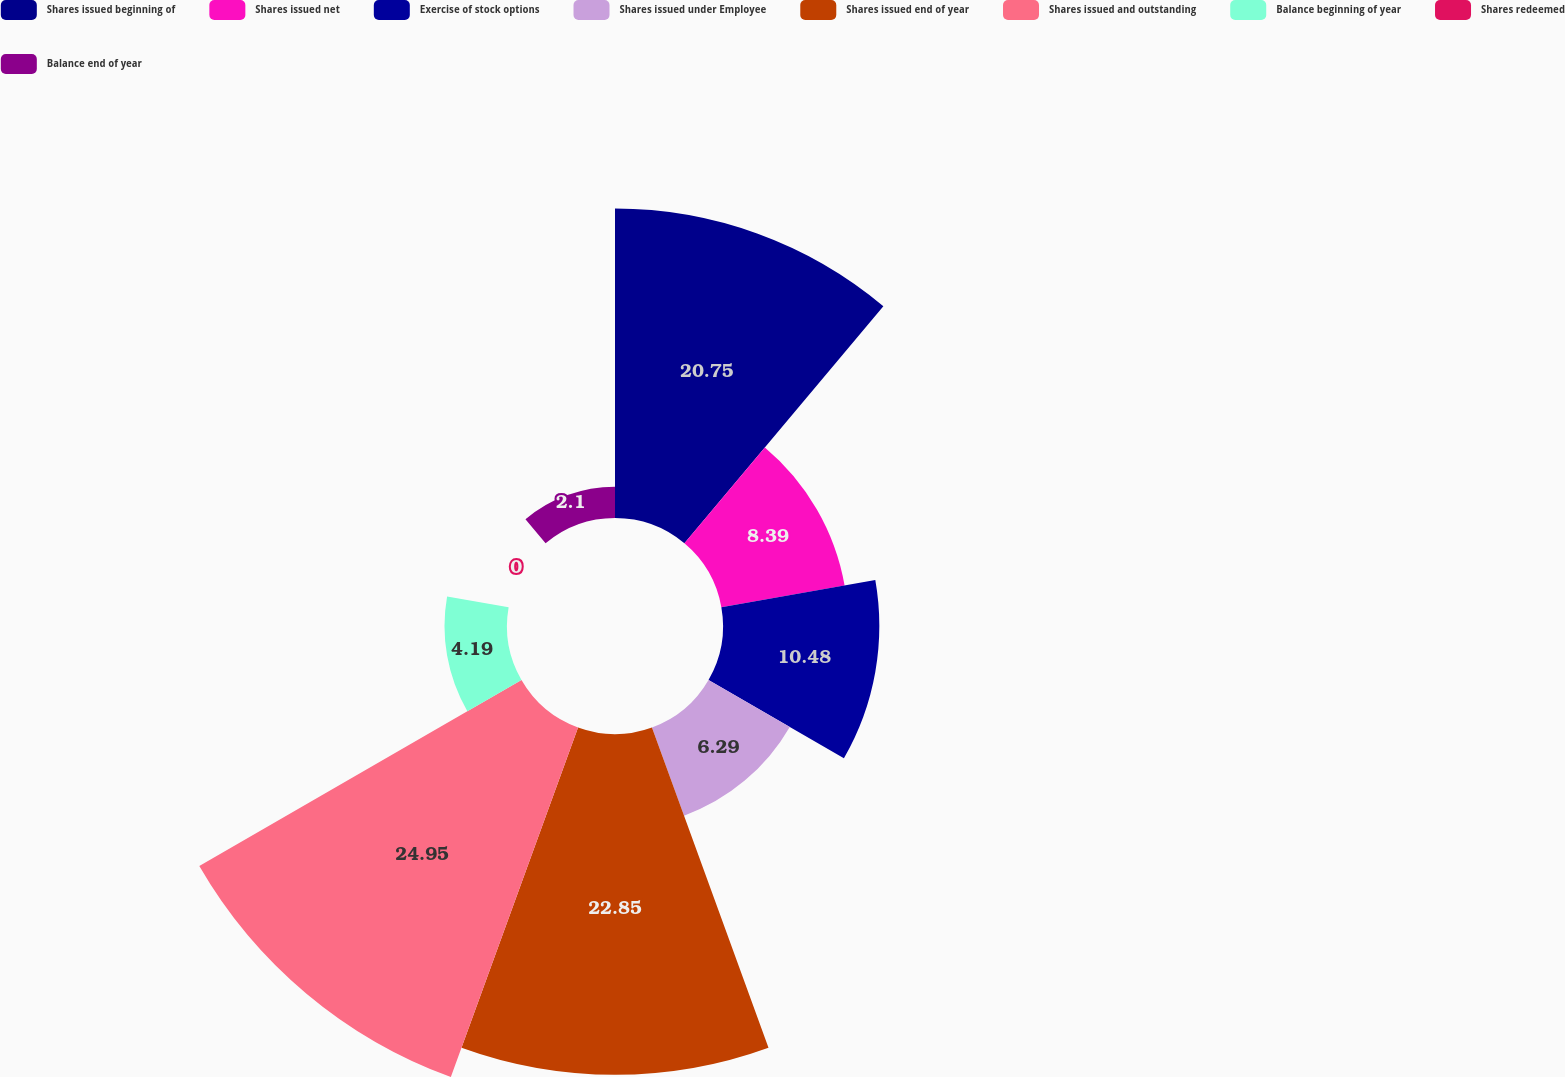Convert chart to OTSL. <chart><loc_0><loc_0><loc_500><loc_500><pie_chart><fcel>Shares issued beginning of<fcel>Shares issued net<fcel>Exercise of stock options<fcel>Shares issued under Employee<fcel>Shares issued end of year<fcel>Shares issued and outstanding<fcel>Balance beginning of year<fcel>Shares redeemed<fcel>Balance end of year<nl><fcel>20.75%<fcel>8.39%<fcel>10.48%<fcel>6.29%<fcel>22.85%<fcel>24.94%<fcel>4.19%<fcel>0.0%<fcel>2.1%<nl></chart> 